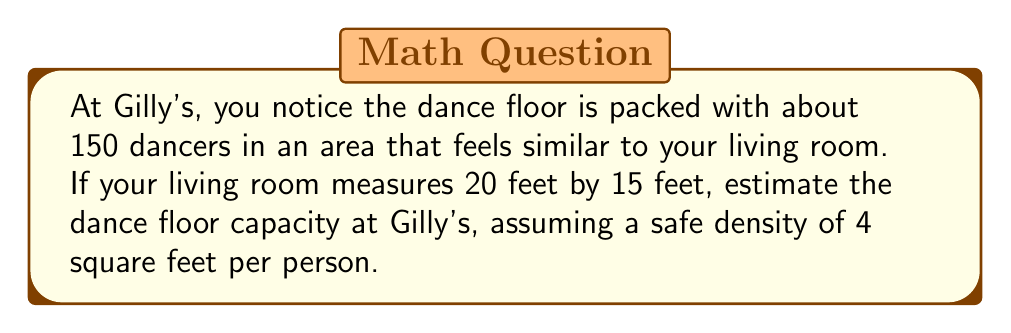Show me your answer to this math problem. Let's approach this step-by-step:

1) First, we need to estimate the area of the dance floor:
   - Your living room measures 20 feet by 15 feet
   - Area of living room = $20 \times 15 = 300$ square feet

2) We're told there are about 150 dancers in this area. Let's calculate the current density:
   - Current density = $\frac{\text{Number of people}}{\text{Area}} = \frac{150}{300} = 0.5$ people per square foot

3) To convert this to square feet per person, we take the reciprocal:
   - Current space per person = $\frac{1}{0.5} = 2$ square feet per person

4) The safe density is given as 4 square feet per person. To find the safe capacity, we need to:
   a) Calculate the total area of the dance floor
   b) Divide this area by the safe space per person

5) Total area of dance floor:
   - Current density: 2 sq ft/person
   - Safe density: 4 sq ft/person
   - Ratio of safe to current: $\frac{4}{2} = 2$
   - Total area = Current area $\times$ 2 = $300 \times 2 = 600$ square feet

6) Safe capacity:
   $$\text{Safe capacity} = \frac{\text{Total area}}{\text{Safe space per person}} = \frac{600}{4} = 150\text{ people}$$

Therefore, the estimated safe dance floor capacity at Gilly's is 150 people.
Answer: 150 people 